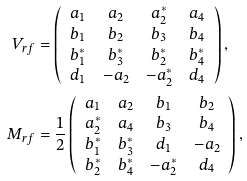<formula> <loc_0><loc_0><loc_500><loc_500>V _ { r f } & = \left ( \begin{array} { c c c c } a _ { 1 } & a _ { 2 } & a _ { 2 } ^ { * } & a _ { 4 } \\ b _ { 1 } & b _ { 2 } & b _ { 3 } & b _ { 4 } \\ b _ { 1 } ^ { * } & b _ { 3 } ^ { * } & b _ { 2 } ^ { * } & b _ { 4 } ^ { * } \\ d _ { 1 } & - a _ { 2 } & - a _ { 2 } ^ { * } & d _ { 4 } \end{array} \right ) , \\ M _ { r f } & = \frac { 1 } { 2 } \left ( \begin{array} { c c c c } a _ { 1 } & a _ { 2 } & b _ { 1 } & b _ { 2 } \\ a _ { 2 } ^ { * } & a _ { 4 } & b _ { 3 } & b _ { 4 } \\ b _ { 1 } ^ { * } & b _ { 3 } ^ { * } & d _ { 1 } & - a _ { 2 } \\ b _ { 2 } ^ { * } & b _ { 4 } ^ { * } & - a _ { 2 } ^ { * } & d _ { 4 } \end{array} \right ) ,</formula> 